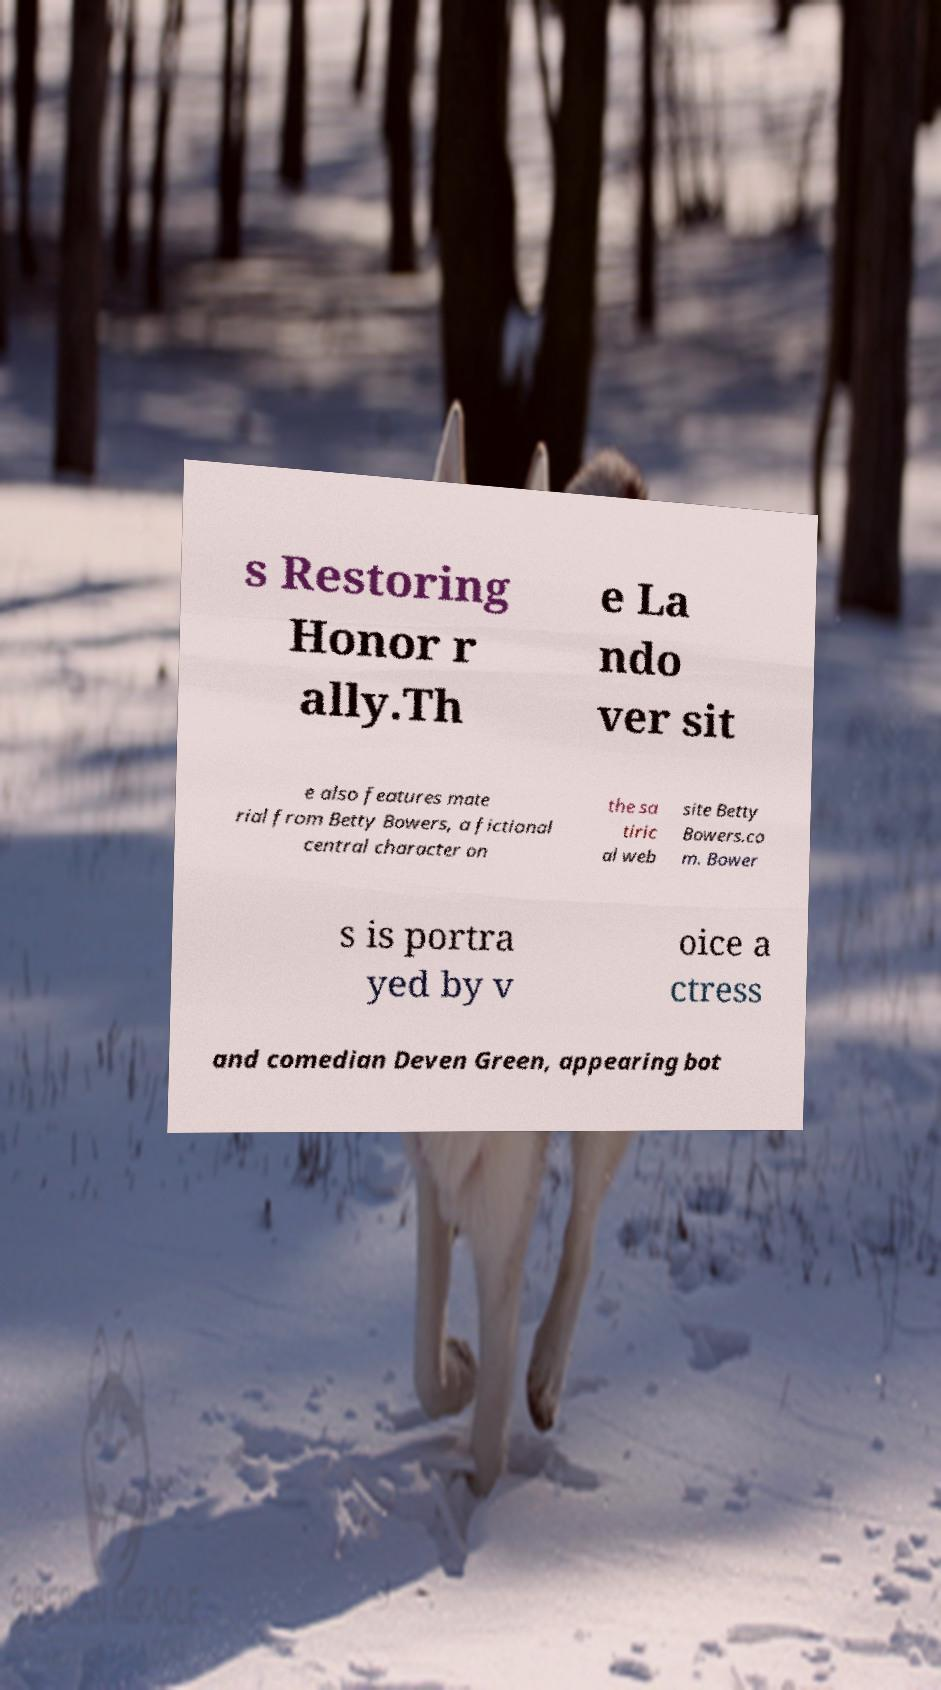There's text embedded in this image that I need extracted. Can you transcribe it verbatim? s Restoring Honor r ally.Th e La ndo ver sit e also features mate rial from Betty Bowers, a fictional central character on the sa tiric al web site Betty Bowers.co m. Bower s is portra yed by v oice a ctress and comedian Deven Green, appearing bot 